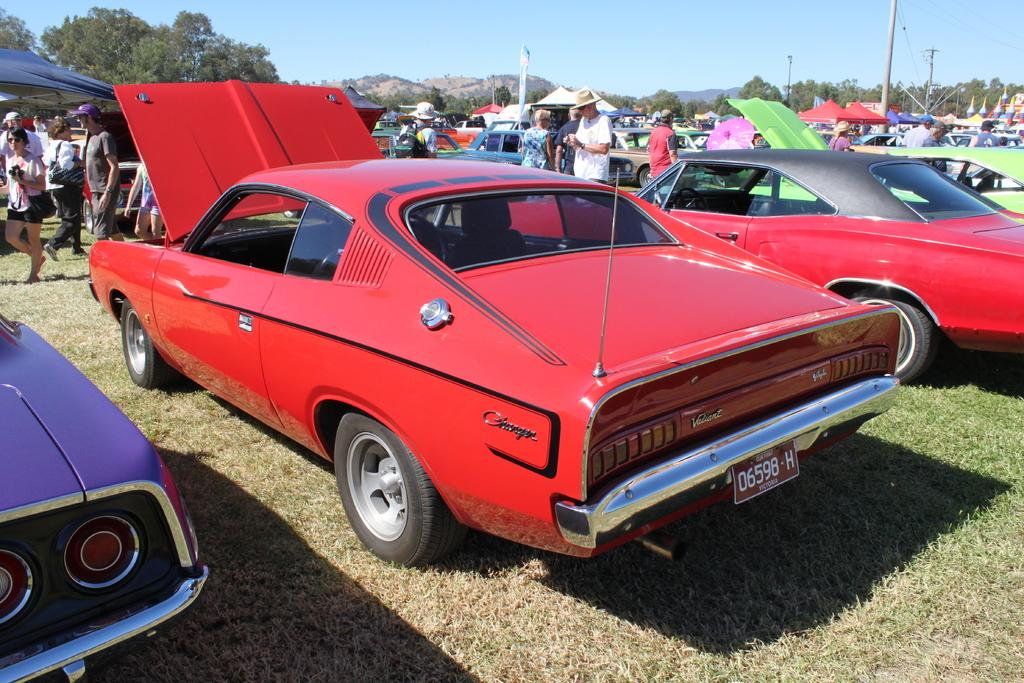What type of vehicles can be seen in the image? There are cars in the image. Who or what else is present in the image? There are people and tents in the image. What structures can be seen in the image? There are poles in the image. What can be seen in the background of the image? There are trees, hills, and the sky visible in the background of the image. What type of terrain is at the bottom of the image? There is grass at the bottom of the image. What color of paint is being used on the grape in the image? There is no grape present in the image, and therefore no paint can be observed. How many skateboards are visible in the image? There are no skateboards present in the image. 